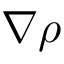<formula> <loc_0><loc_0><loc_500><loc_500>\nabla \rho</formula> 